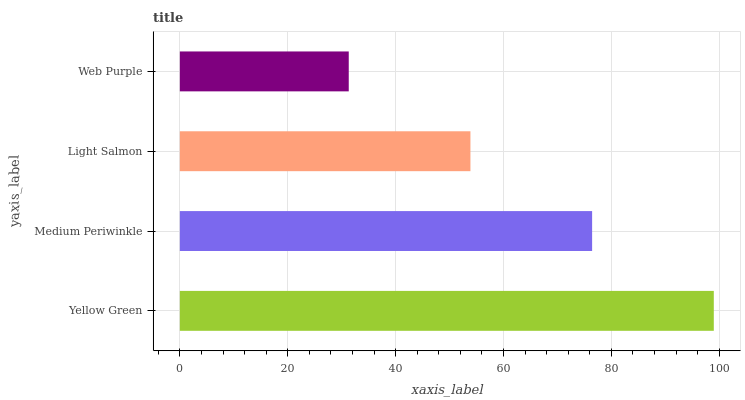Is Web Purple the minimum?
Answer yes or no. Yes. Is Yellow Green the maximum?
Answer yes or no. Yes. Is Medium Periwinkle the minimum?
Answer yes or no. No. Is Medium Periwinkle the maximum?
Answer yes or no. No. Is Yellow Green greater than Medium Periwinkle?
Answer yes or no. Yes. Is Medium Periwinkle less than Yellow Green?
Answer yes or no. Yes. Is Medium Periwinkle greater than Yellow Green?
Answer yes or no. No. Is Yellow Green less than Medium Periwinkle?
Answer yes or no. No. Is Medium Periwinkle the high median?
Answer yes or no. Yes. Is Light Salmon the low median?
Answer yes or no. Yes. Is Yellow Green the high median?
Answer yes or no. No. Is Yellow Green the low median?
Answer yes or no. No. 